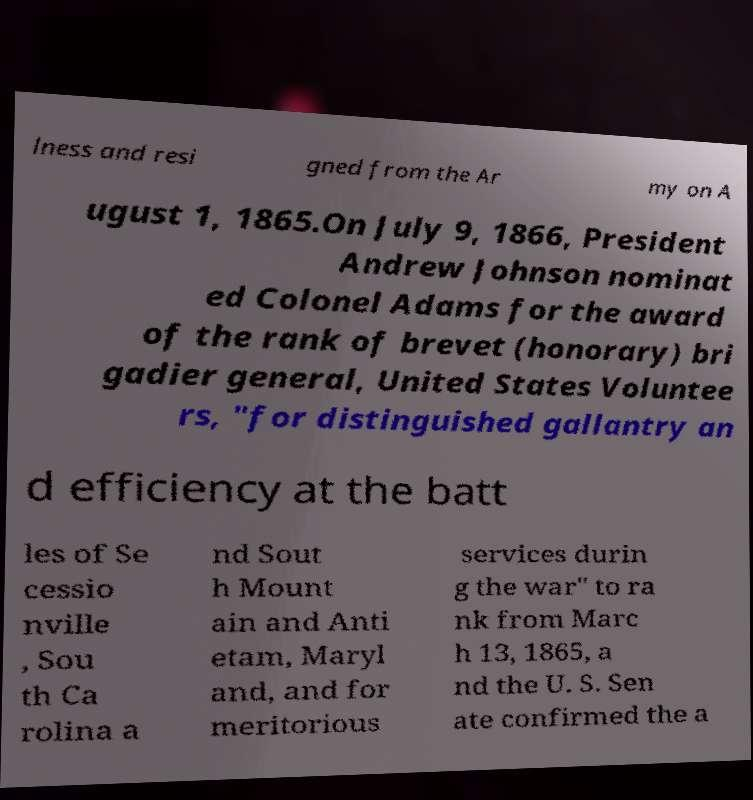Please identify and transcribe the text found in this image. lness and resi gned from the Ar my on A ugust 1, 1865.On July 9, 1866, President Andrew Johnson nominat ed Colonel Adams for the award of the rank of brevet (honorary) bri gadier general, United States Voluntee rs, "for distinguished gallantry an d efficiency at the batt les of Se cessio nville , Sou th Ca rolina a nd Sout h Mount ain and Anti etam, Maryl and, and for meritorious services durin g the war" to ra nk from Marc h 13, 1865, a nd the U. S. Sen ate confirmed the a 